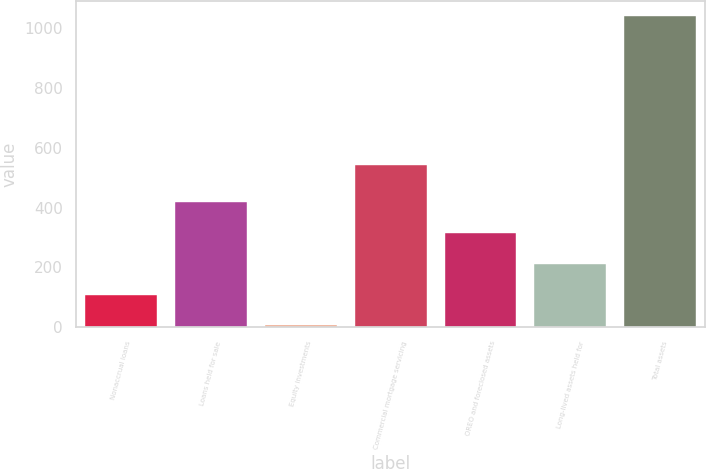Convert chart to OTSL. <chart><loc_0><loc_0><loc_500><loc_500><bar_chart><fcel>Nonaccrual loans<fcel>Loans held for sale<fcel>Equity investments<fcel>Commercial mortgage servicing<fcel>OREO and foreclosed assets<fcel>Long-lived assets held for<fcel>Total assets<nl><fcel>109.4<fcel>419.6<fcel>6<fcel>543<fcel>316.2<fcel>212.8<fcel>1040<nl></chart> 